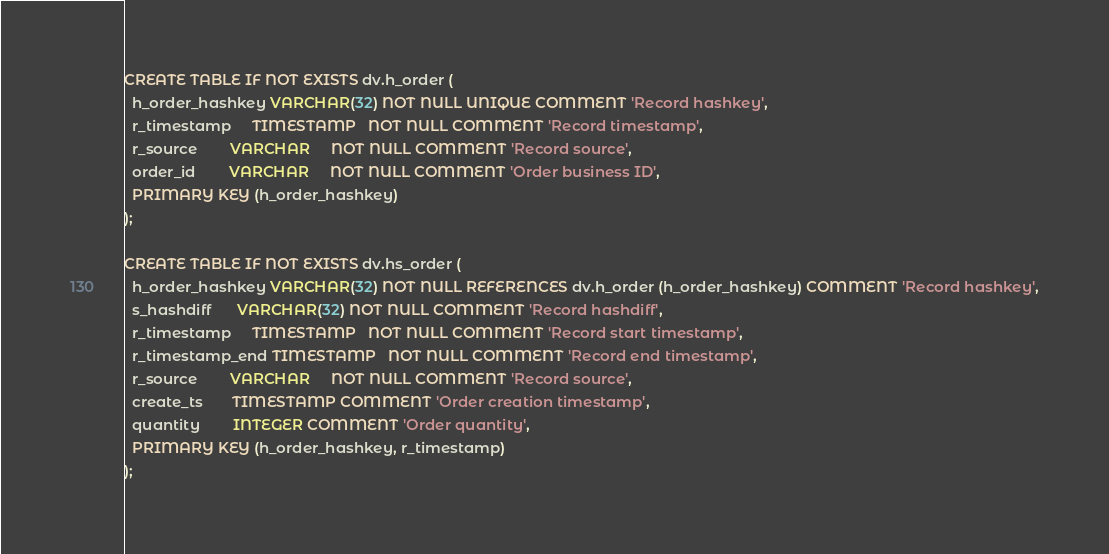<code> <loc_0><loc_0><loc_500><loc_500><_SQL_>CREATE TABLE IF NOT EXISTS dv.h_order (
  h_order_hashkey VARCHAR(32) NOT NULL UNIQUE COMMENT 'Record hashkey',
  r_timestamp     TIMESTAMP   NOT NULL COMMENT 'Record timestamp',
  r_source        VARCHAR     NOT NULL COMMENT 'Record source',
  order_id        VARCHAR     NOT NULL COMMENT 'Order business ID',
  PRIMARY KEY (h_order_hashkey)
);

CREATE TABLE IF NOT EXISTS dv.hs_order (
  h_order_hashkey VARCHAR(32) NOT NULL REFERENCES dv.h_order (h_order_hashkey) COMMENT 'Record hashkey',
  s_hashdiff      VARCHAR(32) NOT NULL COMMENT 'Record hashdiff',
  r_timestamp     TIMESTAMP   NOT NULL COMMENT 'Record start timestamp',
  r_timestamp_end TIMESTAMP   NOT NULL COMMENT 'Record end timestamp',
  r_source        VARCHAR     NOT NULL COMMENT 'Record source',
  create_ts       TIMESTAMP COMMENT 'Order creation timestamp',
  quantity        INTEGER COMMENT 'Order quantity',
  PRIMARY KEY (h_order_hashkey, r_timestamp)
);
</code> 